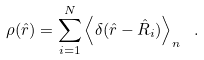Convert formula to latex. <formula><loc_0><loc_0><loc_500><loc_500>\rho ( \hat { r } ) = \sum _ { i = 1 } ^ { N } \left \langle \delta ( \hat { r } - \hat { R } _ { i } ) \right \rangle _ { n } \ .</formula> 